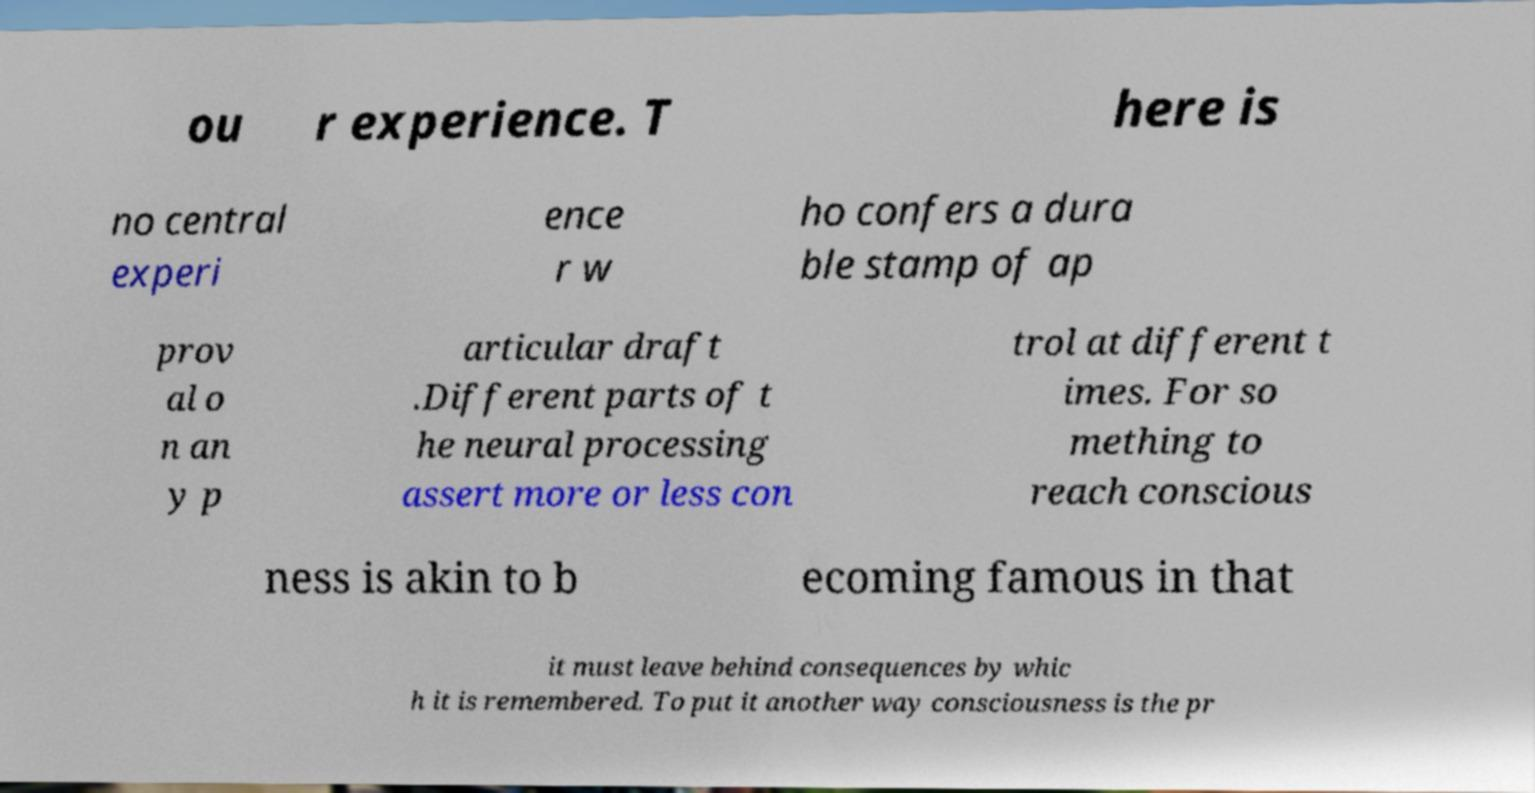Can you accurately transcribe the text from the provided image for me? ou r experience. T here is no central experi ence r w ho confers a dura ble stamp of ap prov al o n an y p articular draft .Different parts of t he neural processing assert more or less con trol at different t imes. For so mething to reach conscious ness is akin to b ecoming famous in that it must leave behind consequences by whic h it is remembered. To put it another way consciousness is the pr 